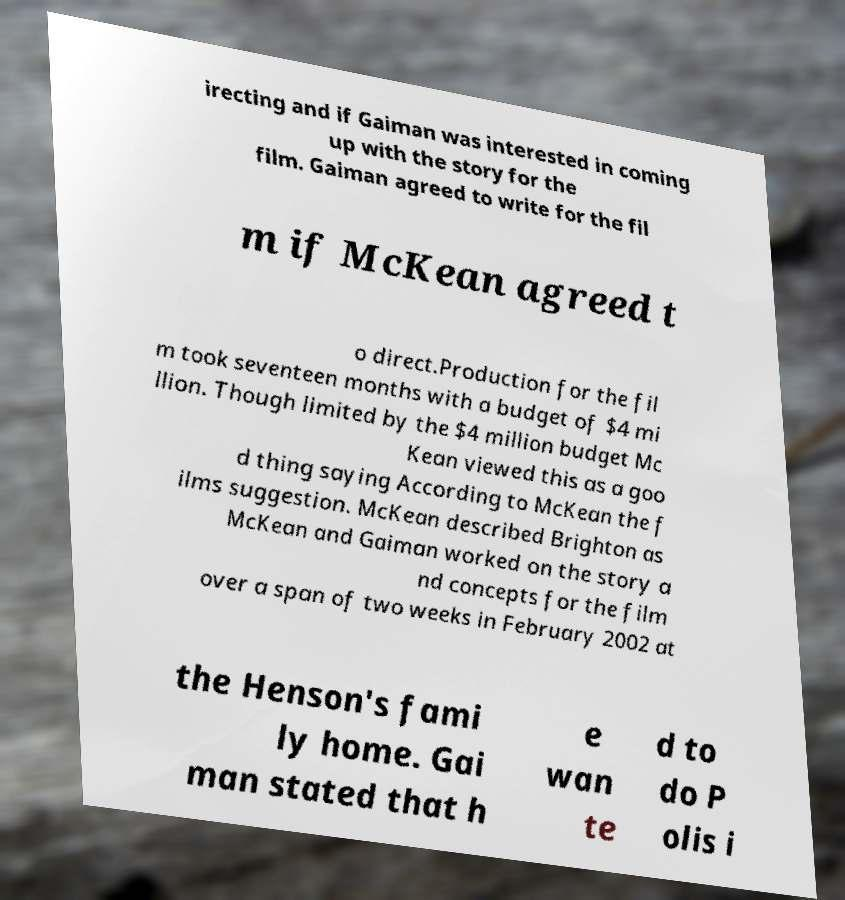I need the written content from this picture converted into text. Can you do that? irecting and if Gaiman was interested in coming up with the story for the film. Gaiman agreed to write for the fil m if McKean agreed t o direct.Production for the fil m took seventeen months with a budget of $4 mi llion. Though limited by the $4 million budget Mc Kean viewed this as a goo d thing saying According to McKean the f ilms suggestion. McKean described Brighton as McKean and Gaiman worked on the story a nd concepts for the film over a span of two weeks in February 2002 at the Henson's fami ly home. Gai man stated that h e wan te d to do P olis i 